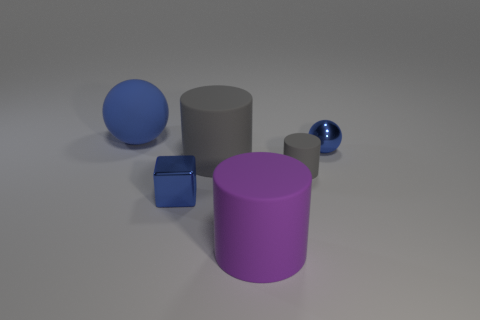What material is the blue object that is the same size as the blue block?
Give a very brief answer. Metal. Is there a big red rubber thing?
Provide a short and direct response. No. What size is the ball that is made of the same material as the large purple object?
Offer a very short reply. Large. Is the material of the large gray cylinder the same as the large blue thing?
Your answer should be compact. Yes. What number of other things are there of the same material as the small cylinder
Keep it short and to the point. 3. What number of things are behind the metallic block and in front of the large sphere?
Your response must be concise. 3. The big ball is what color?
Offer a terse response. Blue. What material is the other small thing that is the same shape as the blue rubber object?
Your answer should be compact. Metal. Is the small metal ball the same color as the small rubber cylinder?
Your answer should be very brief. No. There is a shiny thing in front of the sphere in front of the blue matte ball; what is its shape?
Offer a terse response. Cube. 